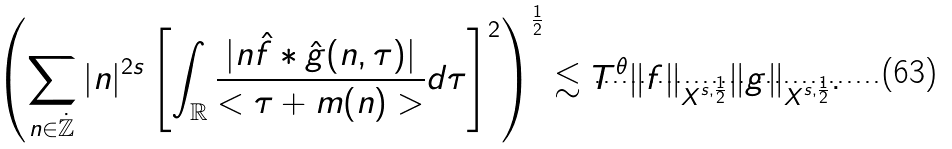Convert formula to latex. <formula><loc_0><loc_0><loc_500><loc_500>\left ( \sum _ { n \in \mathbb { \dot { Z } } } | n | ^ { 2 s } \left [ \int _ { \mathbb { R } } \frac { | n \hat { f } * \hat { g } ( n , \tau ) | } { < \tau + m ( n ) > } d \tau \right ] ^ { 2 } \right ) ^ { \frac { 1 } { 2 } } \lesssim T ^ { \theta } \| f \| _ { X ^ { s , \frac { 1 } { 2 } } } \| g \| _ { X ^ { s , \frac { 1 } { 2 } } } .</formula> 